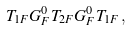<formula> <loc_0><loc_0><loc_500><loc_500>T _ { 1 F } G _ { F } ^ { 0 } T _ { 2 F } G _ { F } ^ { 0 } T _ { 1 F } \, ,</formula> 